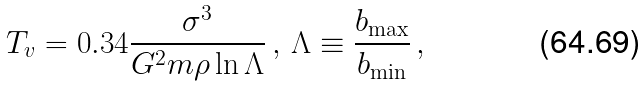<formula> <loc_0><loc_0><loc_500><loc_500>T _ { v } = 0 . 3 4 \frac { \sigma ^ { 3 } } { G ^ { 2 } m \rho \ln \Lambda } \, , \, \Lambda \equiv \frac { b _ { \max } } { b _ { \min } } \, ,</formula> 